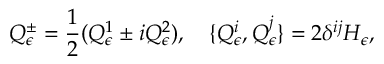<formula> <loc_0><loc_0><loc_500><loc_500>Q _ { \epsilon } ^ { \pm } = \frac { 1 } { 2 } ( Q _ { \epsilon } ^ { 1 } \pm i Q _ { \epsilon } ^ { 2 } ) , \quad \{ Q _ { \epsilon } ^ { i } , Q _ { \epsilon } ^ { j } \} = 2 \delta ^ { i j } H _ { \epsilon } ,</formula> 